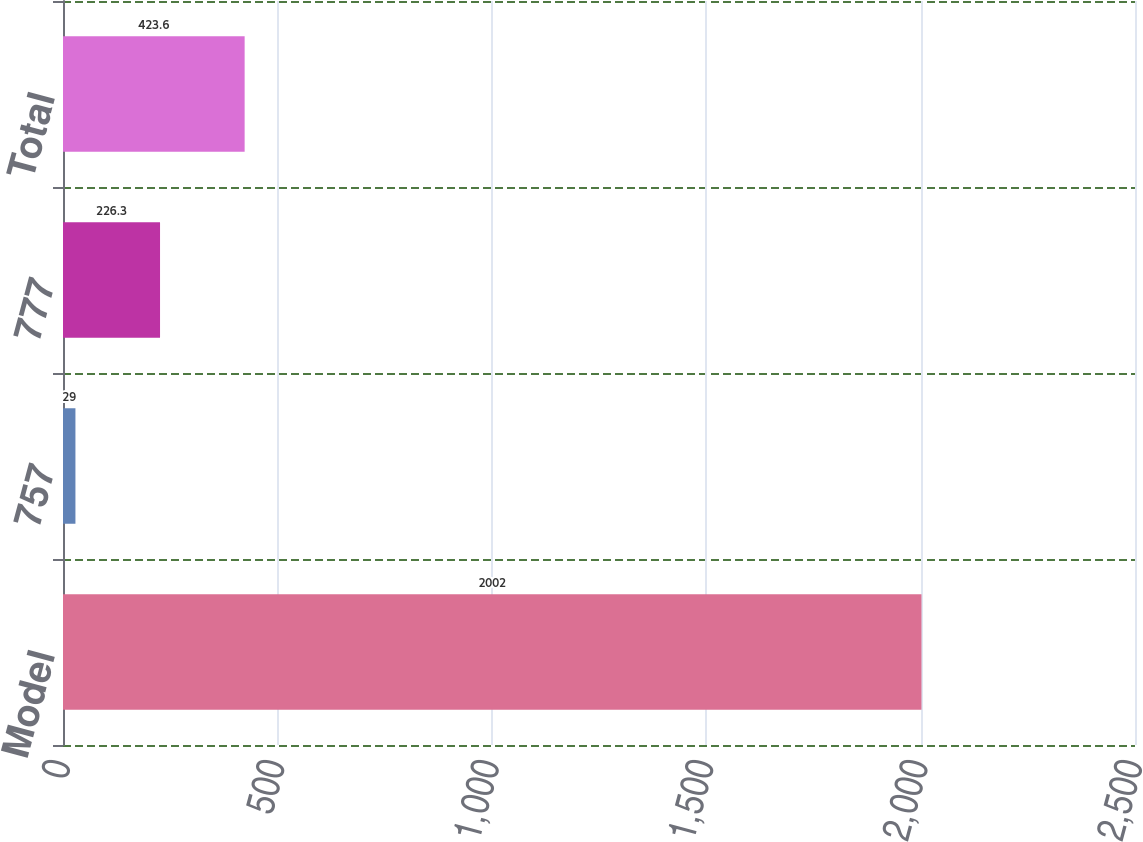<chart> <loc_0><loc_0><loc_500><loc_500><bar_chart><fcel>Model<fcel>757<fcel>777<fcel>Total<nl><fcel>2002<fcel>29<fcel>226.3<fcel>423.6<nl></chart> 